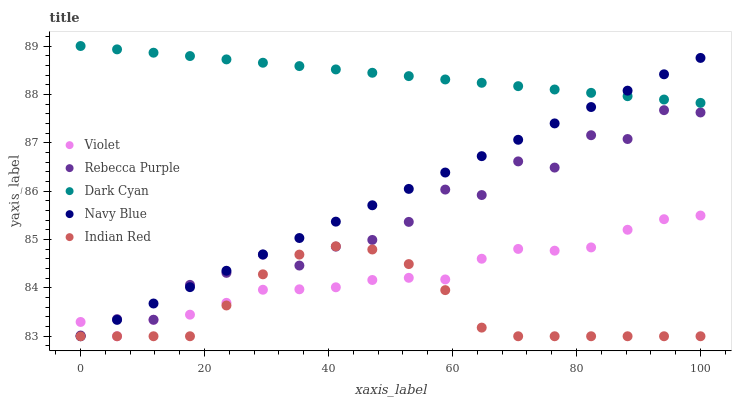Does Indian Red have the minimum area under the curve?
Answer yes or no. Yes. Does Dark Cyan have the maximum area under the curve?
Answer yes or no. Yes. Does Navy Blue have the minimum area under the curve?
Answer yes or no. No. Does Navy Blue have the maximum area under the curve?
Answer yes or no. No. Is Dark Cyan the smoothest?
Answer yes or no. Yes. Is Rebecca Purple the roughest?
Answer yes or no. Yes. Is Navy Blue the smoothest?
Answer yes or no. No. Is Navy Blue the roughest?
Answer yes or no. No. Does Navy Blue have the lowest value?
Answer yes or no. Yes. Does Rebecca Purple have the lowest value?
Answer yes or no. No. Does Dark Cyan have the highest value?
Answer yes or no. Yes. Does Navy Blue have the highest value?
Answer yes or no. No. Is Rebecca Purple less than Dark Cyan?
Answer yes or no. Yes. Is Dark Cyan greater than Rebecca Purple?
Answer yes or no. Yes. Does Violet intersect Rebecca Purple?
Answer yes or no. Yes. Is Violet less than Rebecca Purple?
Answer yes or no. No. Is Violet greater than Rebecca Purple?
Answer yes or no. No. Does Rebecca Purple intersect Dark Cyan?
Answer yes or no. No. 